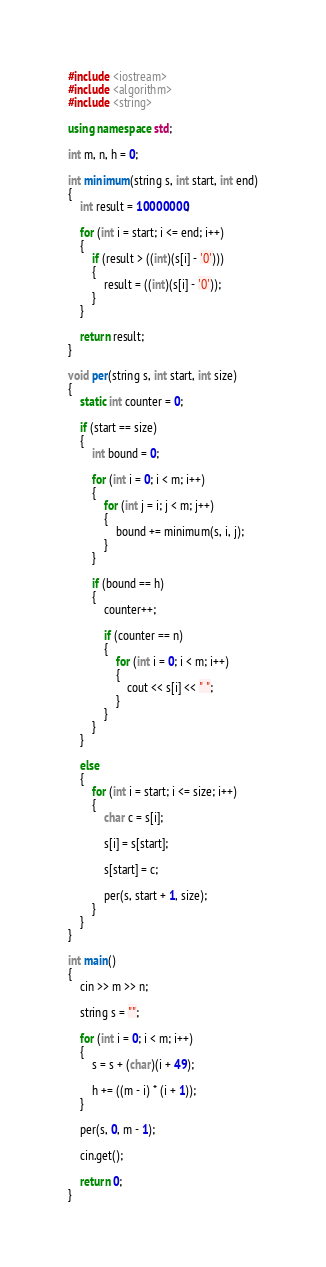Convert code to text. <code><loc_0><loc_0><loc_500><loc_500><_C++_>#include <iostream>
#include <algorithm>
#include <string>

using namespace std;

int m, n, h = 0;

int minimum(string s, int start, int end)
{
	int result = 10000000;

	for (int i = start; i <= end; i++)
	{
		if (result > ((int)(s[i] - '0')))
		{
			result = ((int)(s[i] - '0'));
		}
	}

	return result;
}

void per(string s, int start, int size)
{
	static int counter = 0;

	if (start == size)
	{
		int bound = 0;

		for (int i = 0; i < m; i++)
		{
			for (int j = i; j < m; j++)
			{
				bound += minimum(s, i, j);
			}
		}

		if (bound == h)
		{
			counter++;

			if (counter == n)
			{
				for (int i = 0; i < m; i++)
				{
					cout << s[i] << " ";
				}
			}
		}
	}

	else
	{
		for (int i = start; i <= size; i++)
		{
			char c = s[i];

			s[i] = s[start];

			s[start] = c;

			per(s, start + 1, size);
		}
	}
}

int main()
{
	cin >> m >> n;

	string s = "";

	for (int i = 0; i < m; i++)
	{
		s = s + (char)(i + 49);

		h += ((m - i) * (i + 1));
	}

	per(s, 0, m - 1);

	cin.get();

	return 0;
}</code> 